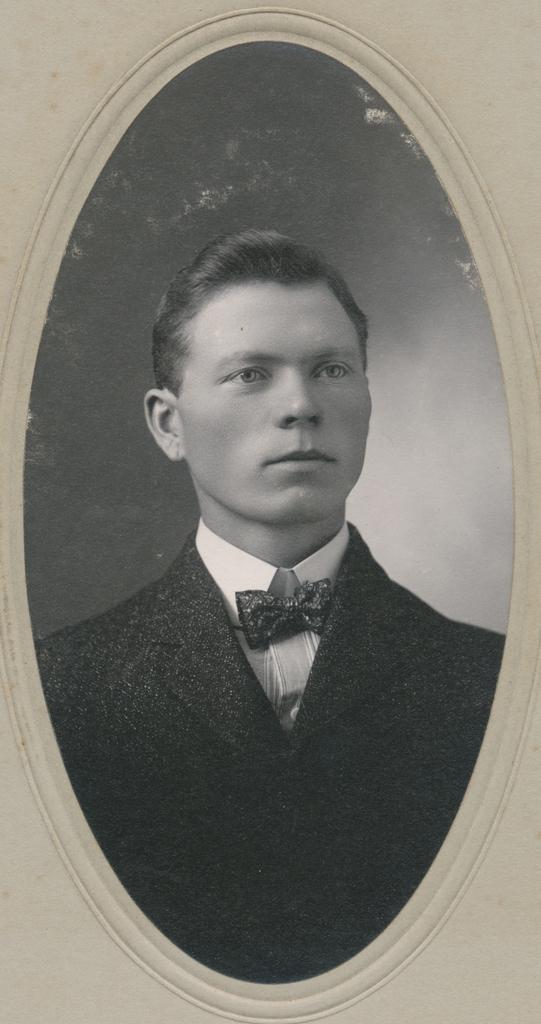Please provide a concise description of this image. In this picture we can see a frame and in this frame we can see a man wearing a blazer, bow tie. 